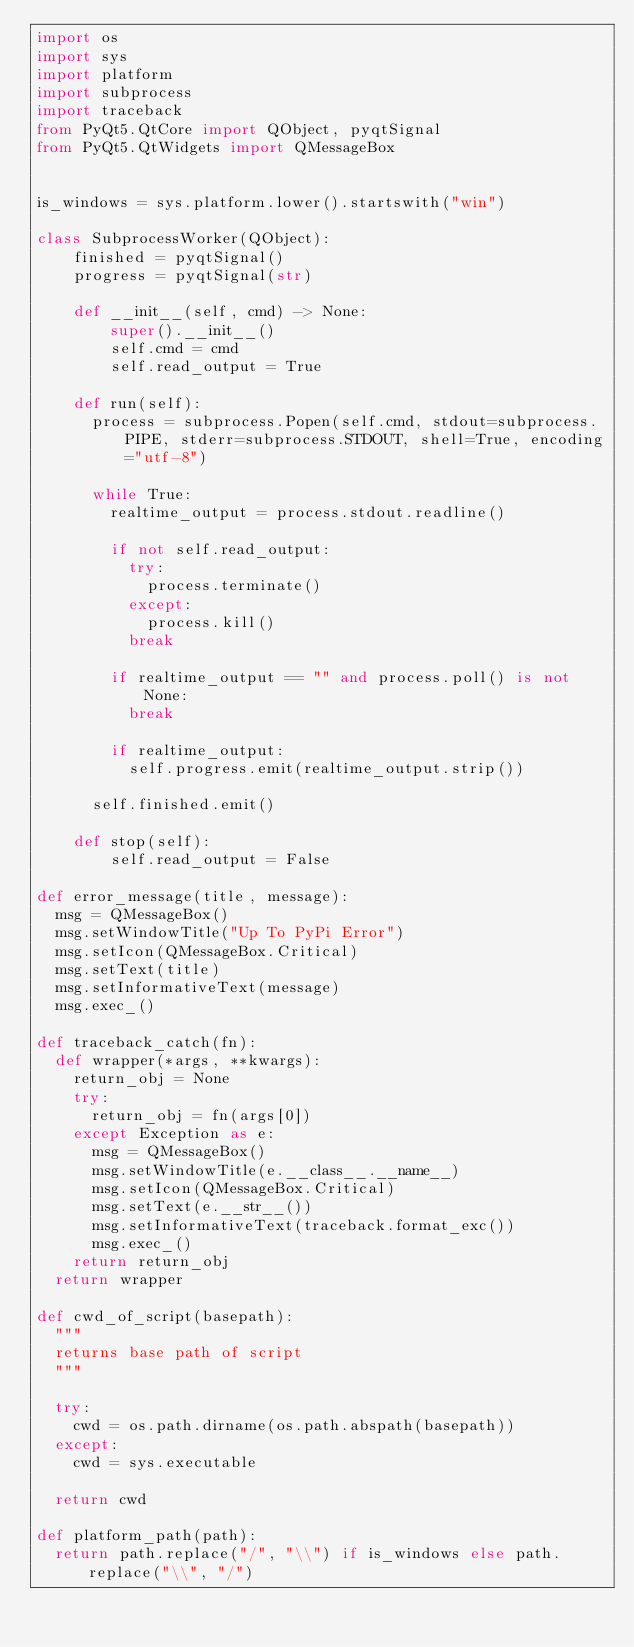<code> <loc_0><loc_0><loc_500><loc_500><_Python_>import os
import sys
import platform
import subprocess
import traceback
from PyQt5.QtCore import QObject, pyqtSignal
from PyQt5.QtWidgets import QMessageBox


is_windows = sys.platform.lower().startswith("win")

class SubprocessWorker(QObject):
    finished = pyqtSignal()
    progress = pyqtSignal(str)

    def __init__(self, cmd) -> None:
        super().__init__()
        self.cmd = cmd
        self.read_output = True

    def run(self):
    	process = subprocess.Popen(self.cmd, stdout=subprocess.PIPE, stderr=subprocess.STDOUT, shell=True, encoding="utf-8")

    	while True:
    		realtime_output = process.stdout.readline()

    		if not self.read_output:
    			try:
    				process.terminate()
    			except:
    				process.kill()
    			break

    		if realtime_output == "" and process.poll() is not None:
    			break

    		if realtime_output:
    			self.progress.emit(realtime_output.strip())

    	self.finished.emit()

    def stop(self):
        self.read_output = False

def error_message(title, message):
	msg = QMessageBox()
	msg.setWindowTitle("Up To PyPi Error")
	msg.setIcon(QMessageBox.Critical)
	msg.setText(title)
	msg.setInformativeText(message)
	msg.exec_()

def traceback_catch(fn):
	def wrapper(*args, **kwargs):
		return_obj = None
		try:
			return_obj = fn(args[0])
		except Exception as e:
			msg = QMessageBox()
			msg.setWindowTitle(e.__class__.__name__)
			msg.setIcon(QMessageBox.Critical)
			msg.setText(e.__str__())
			msg.setInformativeText(traceback.format_exc())
			msg.exec_()			
		return return_obj
	return wrapper

def cwd_of_script(basepath):
	"""
	returns base path of script
	"""
	
	try:
		cwd = os.path.dirname(os.path.abspath(basepath))
	except:
		cwd = sys.executable

	return cwd

def platform_path(path):
	return path.replace("/", "\\") if is_windows else path.replace("\\", "/")
</code> 